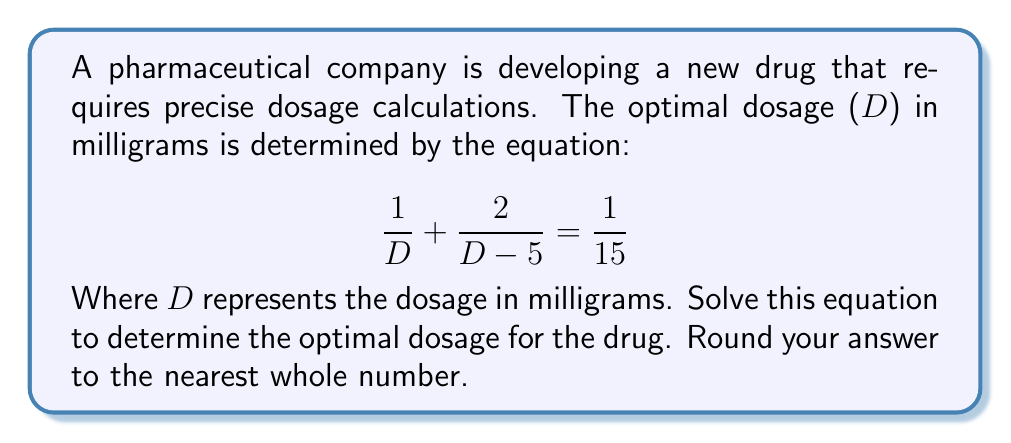Provide a solution to this math problem. Let's solve this step-by-step:

1) First, we need to find a common denominator. The LCD is $15D(D-5)$:

   $$\frac{15(D-5)}{15D(D-5)} + \frac{30}{15D(D-5)} = \frac{D(D-5)}{15D(D-5)}$$

2) Simplify the left side of the equation:

   $$\frac{15D-75+30}{15D(D-5)} = \frac{D(D-5)}{15D(D-5)}$$

3) Simplify further:

   $$\frac{15D-45}{15D(D-5)} = \frac{D(D-5)}{15D(D-5)}$$

4) The denominators are the same, so we can equate the numerators:

   $$15D-45 = D(D-5)$$

5) Expand the right side:

   $$15D-45 = D^2-5D$$

6) Rearrange the equation:

   $$D^2-20D+45 = 0$$

7) This is a quadratic equation. We can solve it using the quadratic formula:
   $$D = \frac{-b \pm \sqrt{b^2-4ac}}{2a}$$

   Where $a=1$, $b=-20$, and $c=45$

8) Plug in the values:

   $$D = \frac{20 \pm \sqrt{400-180}}{2} = \frac{20 \pm \sqrt{220}}{2}$$

9) Simplify:

   $$D = 10 \pm \frac{\sqrt{220}}{2}$$

10) Calculate the two solutions:

    $$D \approx 17.42 \text{ or } 2.58$$

11) Since dosage can't be negative and we're looking for the optimal dosage, we choose the larger value and round to the nearest whole number.
Answer: 17 mg 